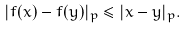<formula> <loc_0><loc_0><loc_500><loc_500>| f ( x ) - f ( y ) | _ { p } \leq | x - y | _ { p } .</formula> 